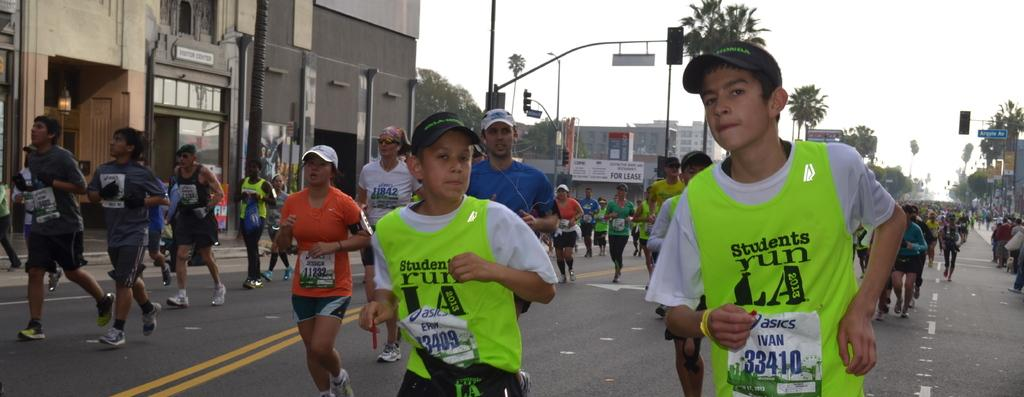What are the people in the image doing? The people in the image are running. What can be seen in the background of the image? There are buildings, trees, poles, boards, and the sky visible in the background of the image. What is at the bottom of the image? There is a road at the bottom of the image. Can you tell me what statement the seashore is making in the image? There is no seashore present in the image, so it cannot make any statements. How many bits are visible in the image? There are no bits present in the image, as it is a photograph and not a digital file. 